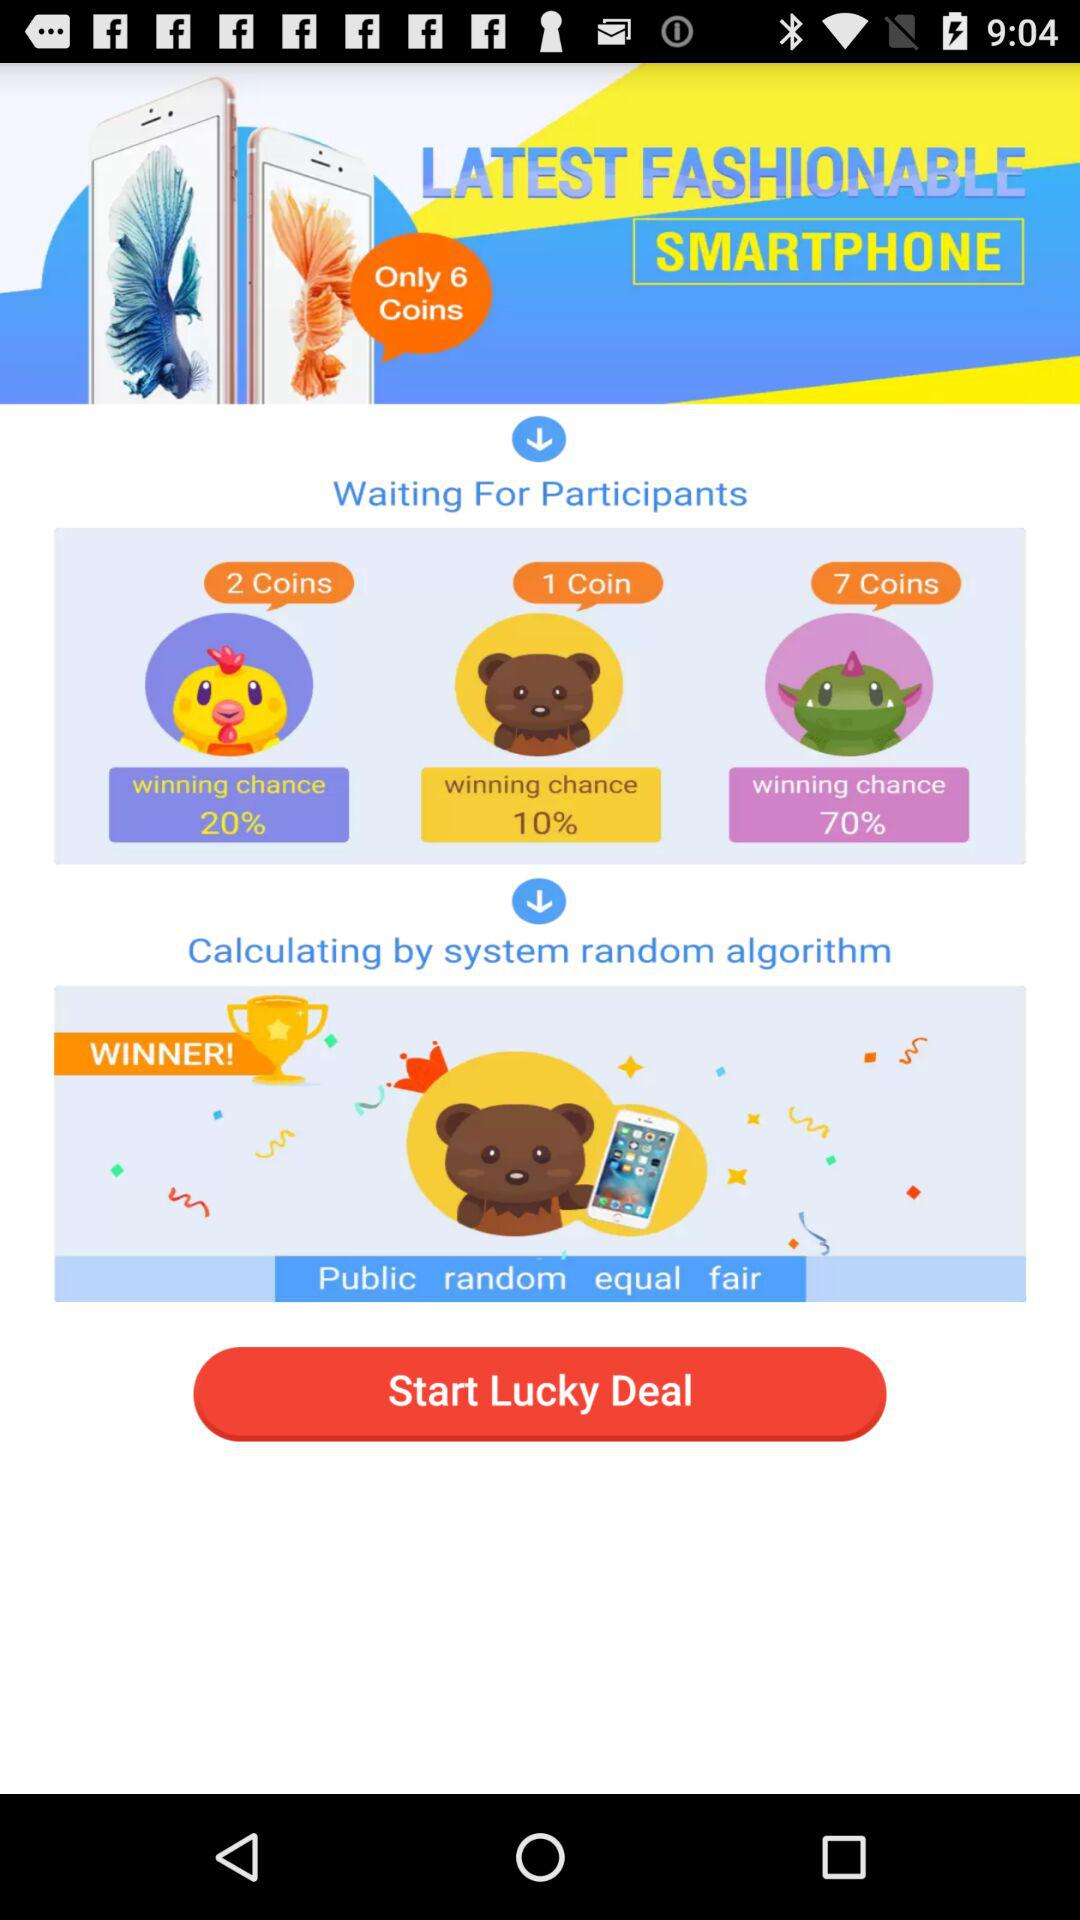Which coin has the highest winning chance?
Answer the question using a single word or phrase. 7 Coins 